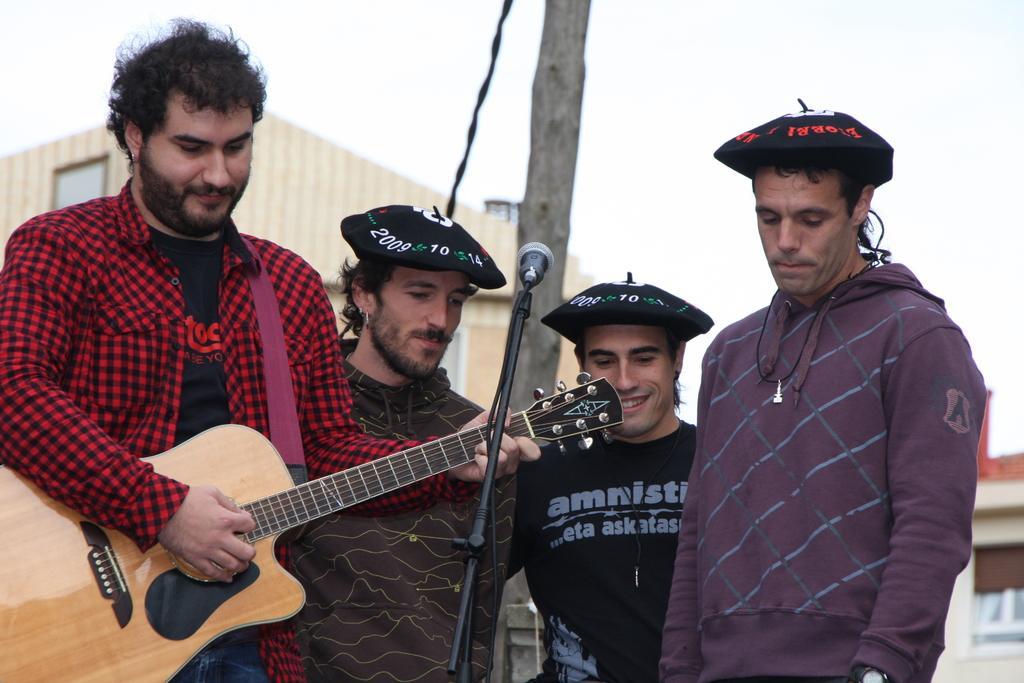Can you describe this image briefly? The four persons are standing in front of the microphone.. They are smiling. The three persons are wearing a cap. On the left side of the person is playing a guitar. We can see in the background pole,house ,sky. 